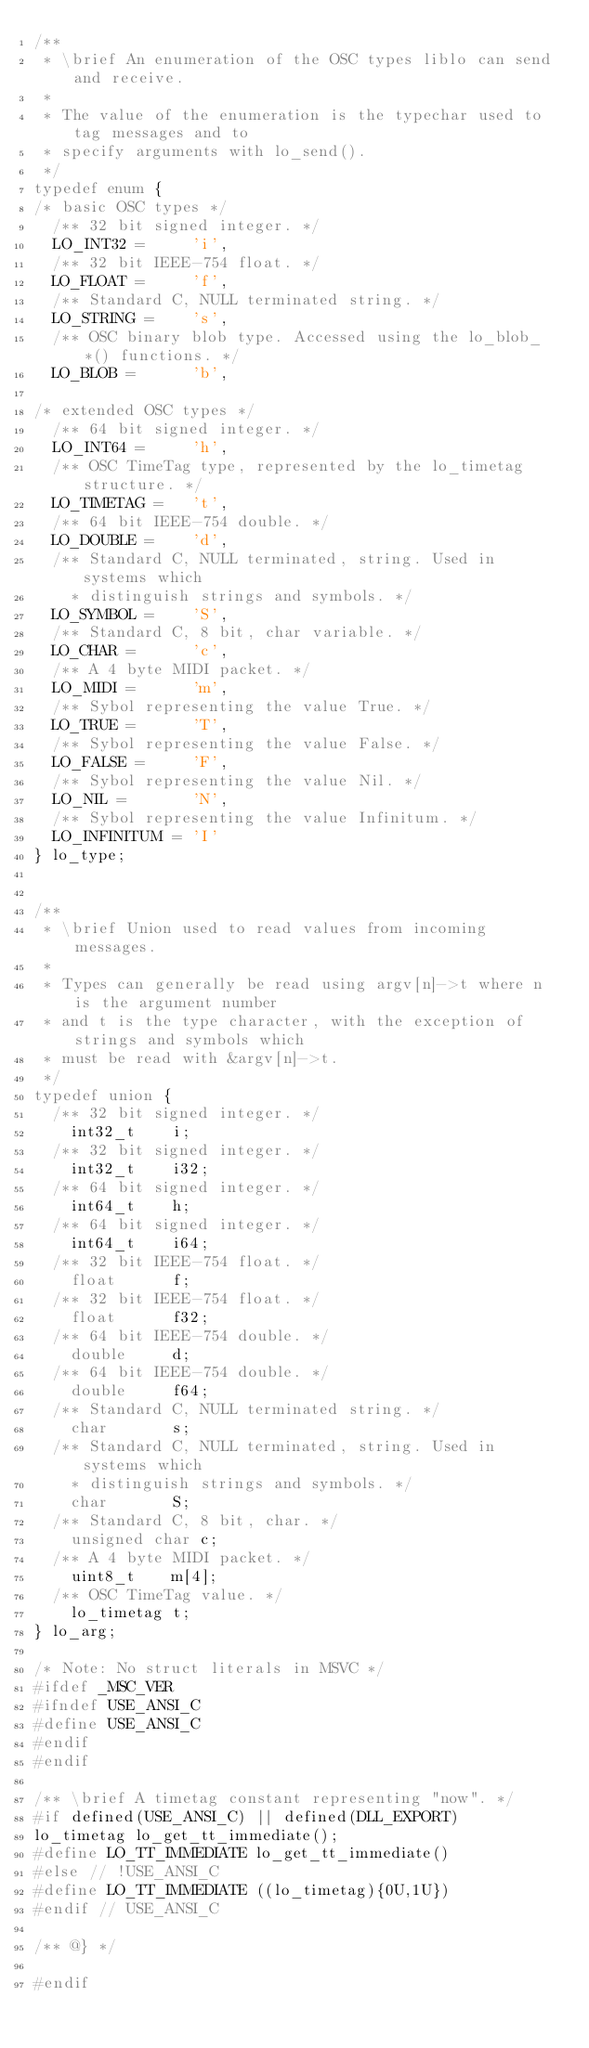<code> <loc_0><loc_0><loc_500><loc_500><_C_>/**
 * \brief An enumeration of the OSC types liblo can send and receive.
 *
 * The value of the enumeration is the typechar used to tag messages and to
 * specify arguments with lo_send().
 */
typedef enum {
/* basic OSC types */
	/** 32 bit signed integer. */
	LO_INT32 =     'i',
	/** 32 bit IEEE-754 float. */
	LO_FLOAT =     'f',
	/** Standard C, NULL terminated string. */
	LO_STRING =    's',
	/** OSC binary blob type. Accessed using the lo_blob_*() functions. */
	LO_BLOB =      'b',

/* extended OSC types */
	/** 64 bit signed integer. */
	LO_INT64 =     'h',
	/** OSC TimeTag type, represented by the lo_timetag structure. */
	LO_TIMETAG =   't',
	/** 64 bit IEEE-754 double. */
	LO_DOUBLE =    'd',
	/** Standard C, NULL terminated, string. Used in systems which
	  * distinguish strings and symbols. */
	LO_SYMBOL =    'S',
	/** Standard C, 8 bit, char variable. */
	LO_CHAR =      'c',
	/** A 4 byte MIDI packet. */
	LO_MIDI =      'm',
	/** Sybol representing the value True. */
	LO_TRUE =      'T',
	/** Sybol representing the value False. */
	LO_FALSE =     'F',
	/** Sybol representing the value Nil. */
	LO_NIL =       'N',
	/** Sybol representing the value Infinitum. */
	LO_INFINITUM = 'I'
} lo_type;


/**
 * \brief Union used to read values from incoming messages.
 *
 * Types can generally be read using argv[n]->t where n is the argument number
 * and t is the type character, with the exception of strings and symbols which
 * must be read with &argv[n]->t.
 */
typedef union {
	/** 32 bit signed integer. */
    int32_t    i;
	/** 32 bit signed integer. */
    int32_t    i32;
	/** 64 bit signed integer. */
    int64_t    h;
	/** 64 bit signed integer. */
    int64_t    i64;
	/** 32 bit IEEE-754 float. */
    float      f;
	/** 32 bit IEEE-754 float. */
    float      f32;
	/** 64 bit IEEE-754 double. */
    double     d;
	/** 64 bit IEEE-754 double. */
    double     f64;
	/** Standard C, NULL terminated string. */
    char       s;
	/** Standard C, NULL terminated, string. Used in systems which
	  * distinguish strings and symbols. */
    char       S;
	/** Standard C, 8 bit, char. */
    unsigned char c;
	/** A 4 byte MIDI packet. */
    uint8_t    m[4];
	/** OSC TimeTag value. */
    lo_timetag t;
} lo_arg;

/* Note: No struct literals in MSVC */
#ifdef _MSC_VER
#ifndef USE_ANSI_C
#define USE_ANSI_C
#endif
#endif

/** \brief A timetag constant representing "now". */
#if defined(USE_ANSI_C) || defined(DLL_EXPORT)
lo_timetag lo_get_tt_immediate();
#define LO_TT_IMMEDIATE lo_get_tt_immediate()
#else // !USE_ANSI_C
#define LO_TT_IMMEDIATE ((lo_timetag){0U,1U})
#endif // USE_ANSI_C

/** @} */

#endif
</code> 